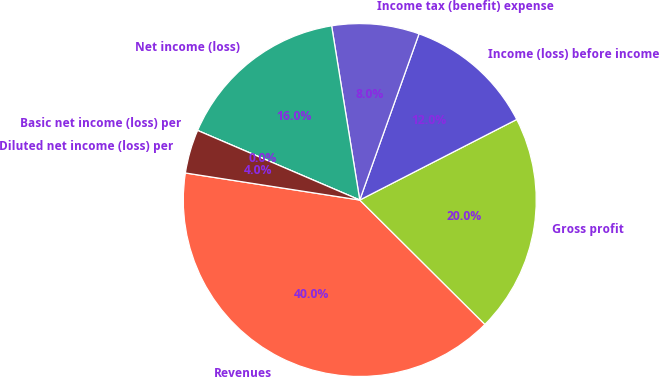Convert chart. <chart><loc_0><loc_0><loc_500><loc_500><pie_chart><fcel>Revenues<fcel>Gross profit<fcel>Income (loss) before income<fcel>Income tax (benefit) expense<fcel>Net income (loss)<fcel>Basic net income (loss) per<fcel>Diluted net income (loss) per<nl><fcel>40.0%<fcel>20.0%<fcel>12.0%<fcel>8.0%<fcel>16.0%<fcel>0.0%<fcel>4.0%<nl></chart> 